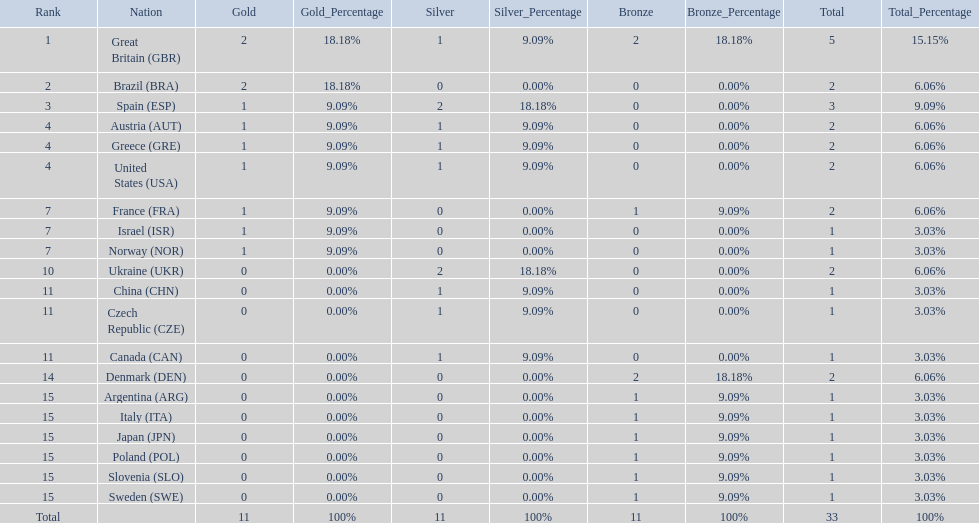What are all of the countries? Great Britain (GBR), Brazil (BRA), Spain (ESP), Austria (AUT), Greece (GRE), United States (USA), France (FRA), Israel (ISR), Norway (NOR), Ukraine (UKR), China (CHN), Czech Republic (CZE), Canada (CAN), Denmark (DEN), Argentina (ARG), Italy (ITA), Japan (JPN), Poland (POL), Slovenia (SLO), Sweden (SWE). Which ones earned a medal? Great Britain (GBR), Brazil (BRA), Spain (ESP), Austria (AUT), Greece (GRE), United States (USA), France (FRA), Israel (ISR), Norway (NOR), Ukraine (UKR), China (CHN), Czech Republic (CZE), Canada (CAN), Denmark (DEN), Argentina (ARG), Italy (ITA), Japan (JPN), Poland (POL), Slovenia (SLO), Sweden (SWE). Which countries earned at least 3 medals? Great Britain (GBR), Spain (ESP). Which country earned 3 medals? Spain (ESP). 